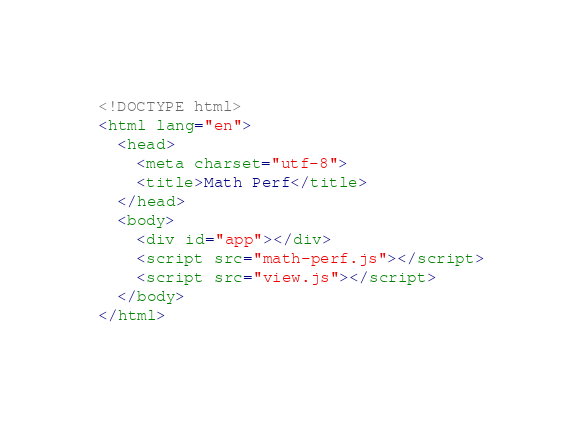Convert code to text. <code><loc_0><loc_0><loc_500><loc_500><_HTML_><!DOCTYPE html>
<html lang="en">
  <head>
    <meta charset="utf-8">
    <title>Math Perf</title>
  </head>
  <body>
    <div id="app"></div>
    <script src="math-perf.js"></script>
    <script src="view.js"></script>
  </body>
</html>
</code> 